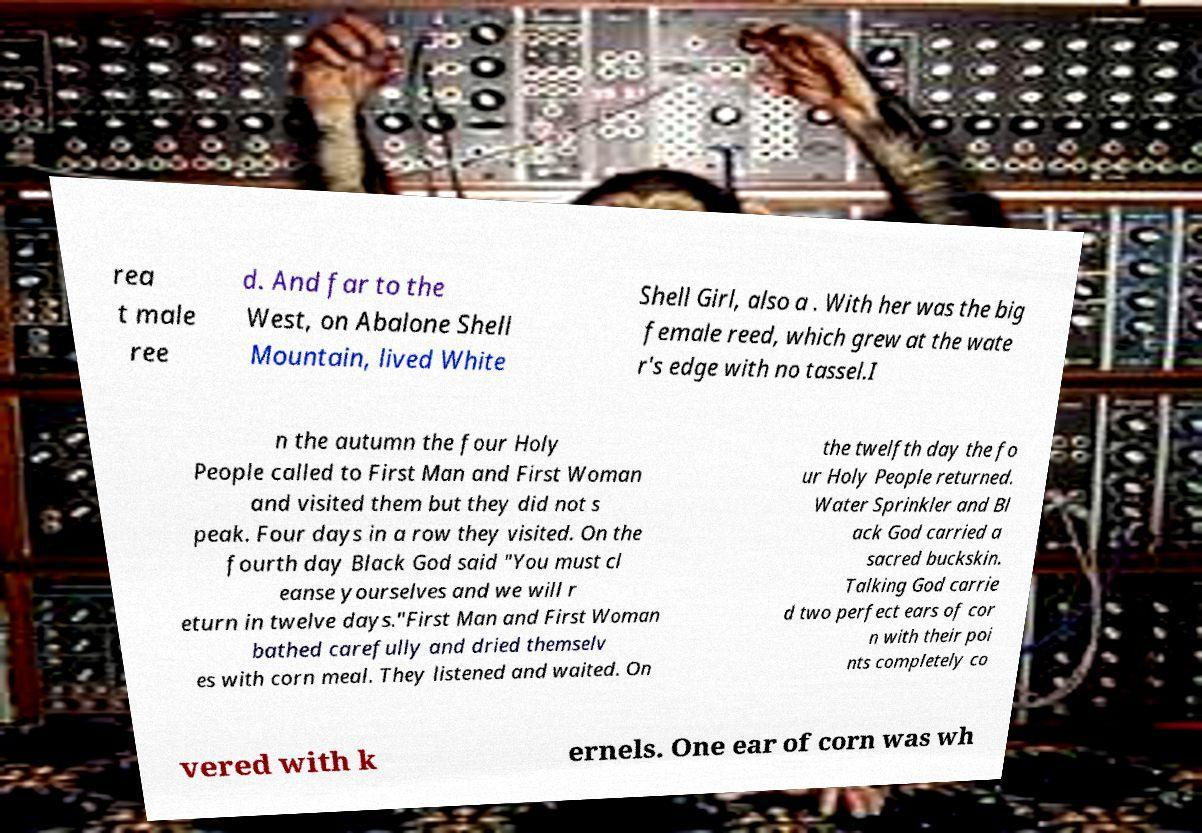Could you extract and type out the text from this image? rea t male ree d. And far to the West, on Abalone Shell Mountain, lived White Shell Girl, also a . With her was the big female reed, which grew at the wate r's edge with no tassel.I n the autumn the four Holy People called to First Man and First Woman and visited them but they did not s peak. Four days in a row they visited. On the fourth day Black God said "You must cl eanse yourselves and we will r eturn in twelve days."First Man and First Woman bathed carefully and dried themselv es with corn meal. They listened and waited. On the twelfth day the fo ur Holy People returned. Water Sprinkler and Bl ack God carried a sacred buckskin. Talking God carrie d two perfect ears of cor n with their poi nts completely co vered with k ernels. One ear of corn was wh 